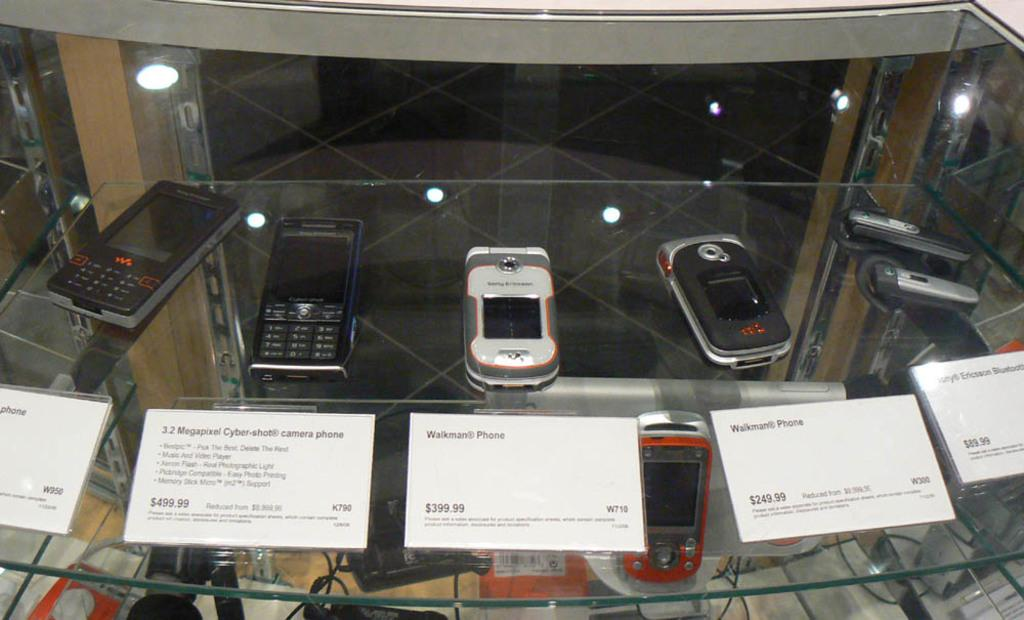<image>
Summarize the visual content of the image. Five older cell phones ranging in price from $89.99 to $499.99 